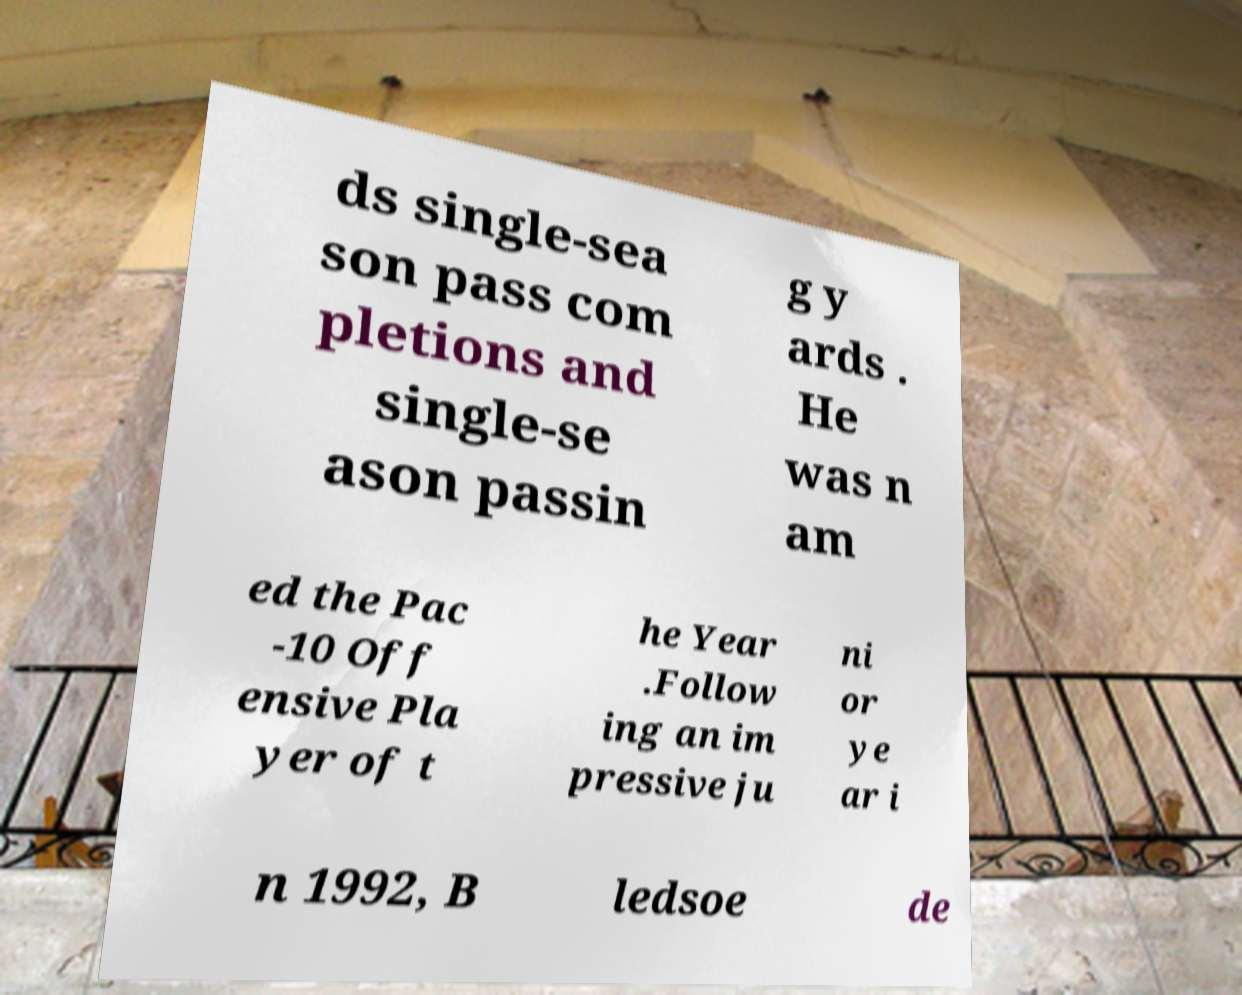There's text embedded in this image that I need extracted. Can you transcribe it verbatim? ds single-sea son pass com pletions and single-se ason passin g y ards . He was n am ed the Pac -10 Off ensive Pla yer of t he Year .Follow ing an im pressive ju ni or ye ar i n 1992, B ledsoe de 